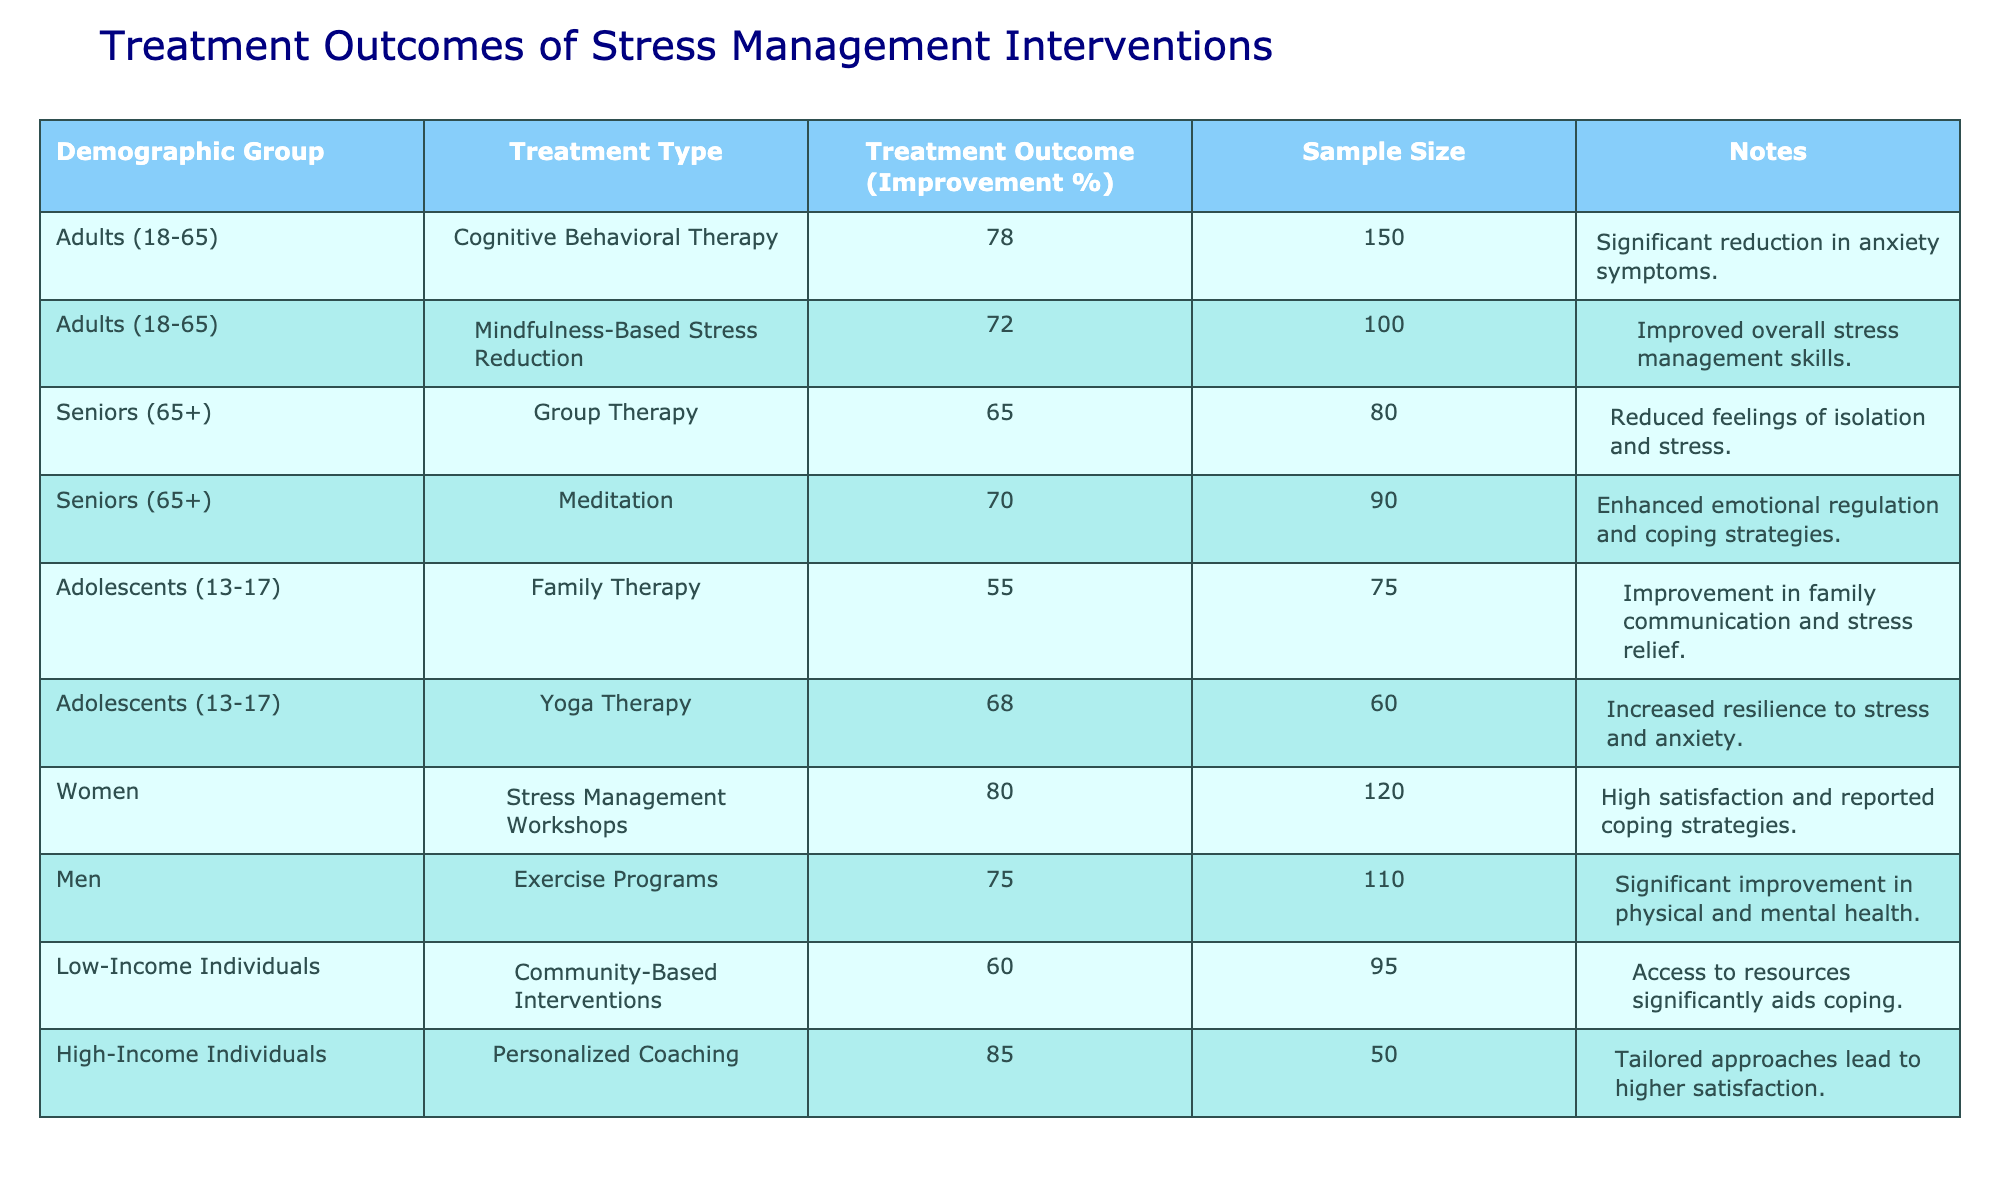What is the highest treatment outcome percentage recorded for a demographic group? The table indicates the treatment outcome percentage for "High-Income Individuals" receiving "Personalized Coaching" is 85%. This is the highest value when comparing all the outcomes listed for different groups.
Answer: 85 Which treatment type had the lowest average improvement percentage among adolescents? The improvement percentages for the two treatments for adolescents are 55% for "Family Therapy" and 68% for "Yoga Therapy". The average is calculated as (55 + 68) / 2 = 61.5%, making "Family Therapy" the treatment with the lowest improvement.
Answer: 61.5 Did "Group Therapy" for seniors result in a higher improvement percentage than "Meditation"? "Group Therapy" resulted in a 65% improvement, while "Meditation" resulted in a 70% improvement. Therefore, "Group Therapy" did not achieve a higher outcome than "Meditation".
Answer: No What is the total sample size for treatments received by women and seniors combined? For women, the sample size is 120, and for seniors, it consists of 80 from "Group Therapy" and 90 from "Meditation", totaling 170 (80 + 90). Adding both gives 120 + 170 = 290.
Answer: 290 Which demographic group showed the most significant improvement percentage from their treatment, and what was that percentage? "High-Income Individuals" experienced the most significant improvement at 85% with "Personalized Coaching", surpassing all other groups' treatments listed in the table.
Answer: 85 How many treatments resulted in an improvement percentage of 70% or more? The treatments that resulted in 70% or more are "Cognitive Behavioral Therapy" (78%), "Mindfulness-Based Stress Reduction" (72%), "Meditation" (70%), "Yoga Therapy" (68%), and "Personalized Coaching" (85%). The count is 4 that meet the criteria.
Answer: 4 What is the difference in treatment outcome percentage between "Stress Management Workshops" and "Community-Based Interventions"? "Stress Management Workshops" have an improvement percentage of 80%, while "Community-Based Interventions" have 60%. The difference is calculated as 80 - 60 = 20%.
Answer: 20 Which group had higher improvement: "Adolescents (13-17)" in "Family Therapy" or "Seniors (65+)" in "Group Therapy"? "Adolescents" improved by 55% in "Family Therapy", while "Seniors" improved by 65% in "Group Therapy". Therefore, seniors had a higher improvement percentage.
Answer: Seniors What is the relationship between income level and treatment outcome percentage based on the data shown? From the table, "High-Income Individuals" had the highest improvement percentage at 85%, while "Low-Income Individuals" had 60%. This suggests that higher income may correlate with better treatment outcomes, as indicated by the substantial difference of 25%.
Answer: Higher income correlates with better outcomes 